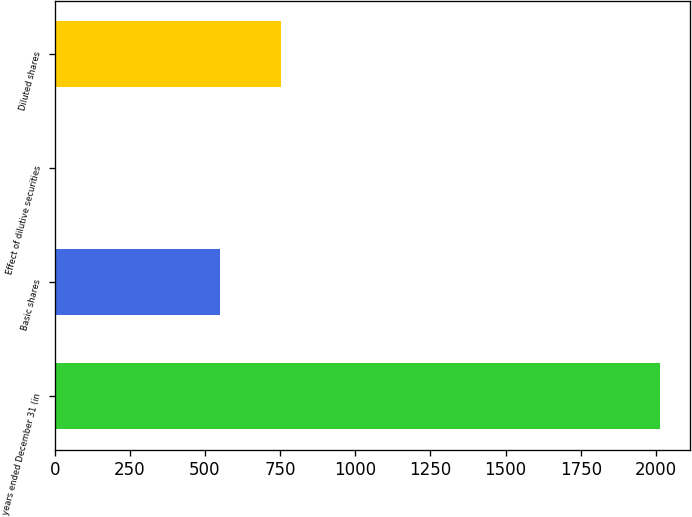<chart> <loc_0><loc_0><loc_500><loc_500><bar_chart><fcel>years ended December 31 (in<fcel>Basic shares<fcel>Effect of dilutive securities<fcel>Diluted shares<nl><fcel>2012<fcel>551<fcel>5<fcel>751.7<nl></chart> 